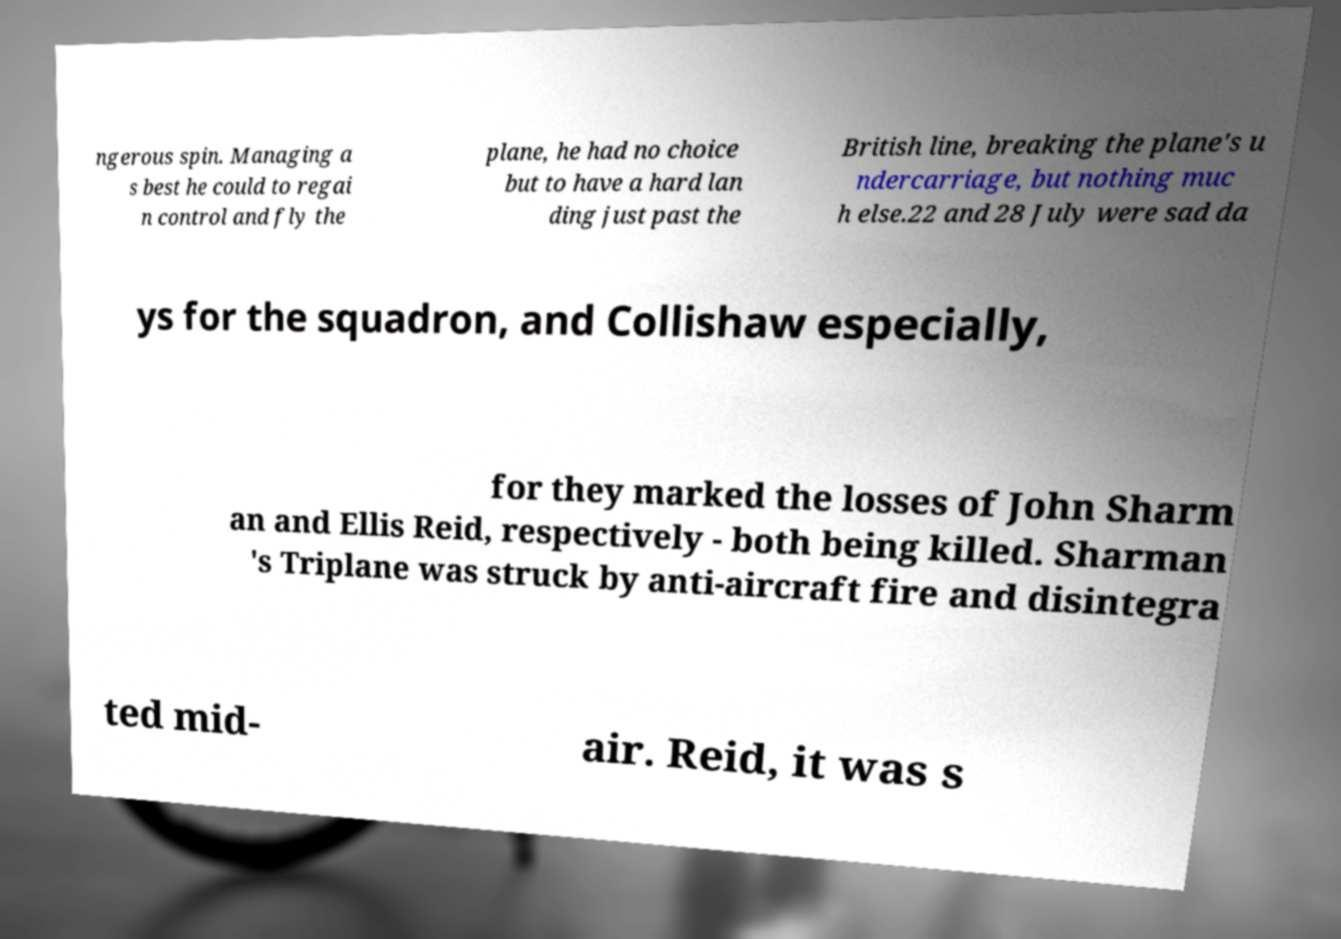Please identify and transcribe the text found in this image. ngerous spin. Managing a s best he could to regai n control and fly the plane, he had no choice but to have a hard lan ding just past the British line, breaking the plane's u ndercarriage, but nothing muc h else.22 and 28 July were sad da ys for the squadron, and Collishaw especially, for they marked the losses of John Sharm an and Ellis Reid, respectively - both being killed. Sharman 's Triplane was struck by anti-aircraft fire and disintegra ted mid- air. Reid, it was s 